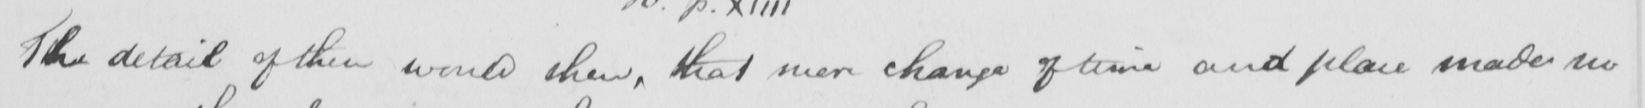What is written in this line of handwriting? The detail of this would then , that mere change of time and place made no 